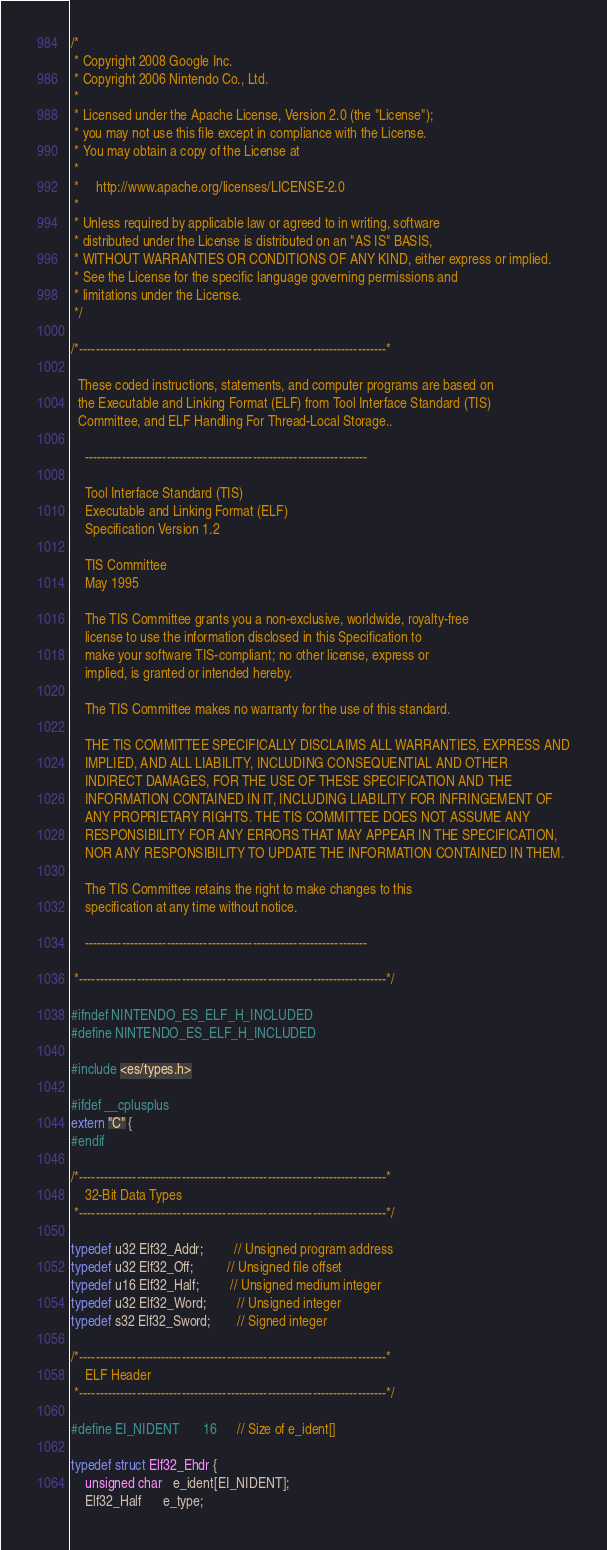Convert code to text. <code><loc_0><loc_0><loc_500><loc_500><_C_>/*
 * Copyright 2008 Google Inc.
 * Copyright 2006 Nintendo Co., Ltd.
 *  
 * Licensed under the Apache License, Version 2.0 (the "License");
 * you may not use this file except in compliance with the License.
 * You may obtain a copy of the License at
 *
 *     http://www.apache.org/licenses/LICENSE-2.0
 *
 * Unless required by applicable law or agreed to in writing, software
 * distributed under the License is distributed on an "AS IS" BASIS,
 * WITHOUT WARRANTIES OR CONDITIONS OF ANY KIND, either express or implied.
 * See the License for the specific language governing permissions and
 * limitations under the License.
 */

/*---------------------------------------------------------------------------*

  These coded instructions, statements, and computer programs are based on
  the Executable and Linking Format (ELF) from Tool Interface Standard (TIS)
  Committee, and ELF Handling For Thread-Local Storage..

    ---------------------------------------------------------------------

    Tool Interface Standard (TIS)
    Executable and Linking Format (ELF)
    Specification Version 1.2

    TIS Committee
    May 1995

    The TIS Committee grants you a non-exclusive, worldwide, royalty-free
    license to use the information disclosed in this Specification to
    make your software TIS-compliant; no other license, express or
    implied, is granted or intended hereby.

    The TIS Committee makes no warranty for the use of this standard.

    THE TIS COMMITTEE SPECIFICALLY DISCLAIMS ALL WARRANTIES, EXPRESS AND
    IMPLIED, AND ALL LIABILITY, INCLUDING CONSEQUENTIAL AND OTHER
    INDIRECT DAMAGES, FOR THE USE OF THESE SPECIFICATION AND THE
    INFORMATION CONTAINED IN IT, INCLUDING LIABILITY FOR INFRINGEMENT OF
    ANY PROPRIETARY RIGHTS. THE TIS COMMITTEE DOES NOT ASSUME ANY
    RESPONSIBILITY FOR ANY ERRORS THAT MAY APPEAR IN THE SPECIFICATION,
    NOR ANY RESPONSIBILITY TO UPDATE THE INFORMATION CONTAINED IN THEM.

    The TIS Committee retains the right to make changes to this
    specification at any time without notice.

    ---------------------------------------------------------------------

 *---------------------------------------------------------------------------*/

#ifndef NINTENDO_ES_ELF_H_INCLUDED
#define NINTENDO_ES_ELF_H_INCLUDED

#include <es/types.h>

#ifdef __cplusplus
extern "C" {
#endif

/*---------------------------------------------------------------------------*
    32-Bit Data Types
 *---------------------------------------------------------------------------*/

typedef u32 Elf32_Addr;         // Unsigned program address
typedef u32 Elf32_Off;          // Unsigned file offset
typedef u16 Elf32_Half;         // Unsigned medium integer
typedef u32 Elf32_Word;         // Unsigned integer
typedef s32 Elf32_Sword;        // Signed integer

/*---------------------------------------------------------------------------*
    ELF Header
 *---------------------------------------------------------------------------*/

#define EI_NIDENT       16      // Size of e_ident[]

typedef struct Elf32_Ehdr {
    unsigned char   e_ident[EI_NIDENT];
    Elf32_Half      e_type;</code> 